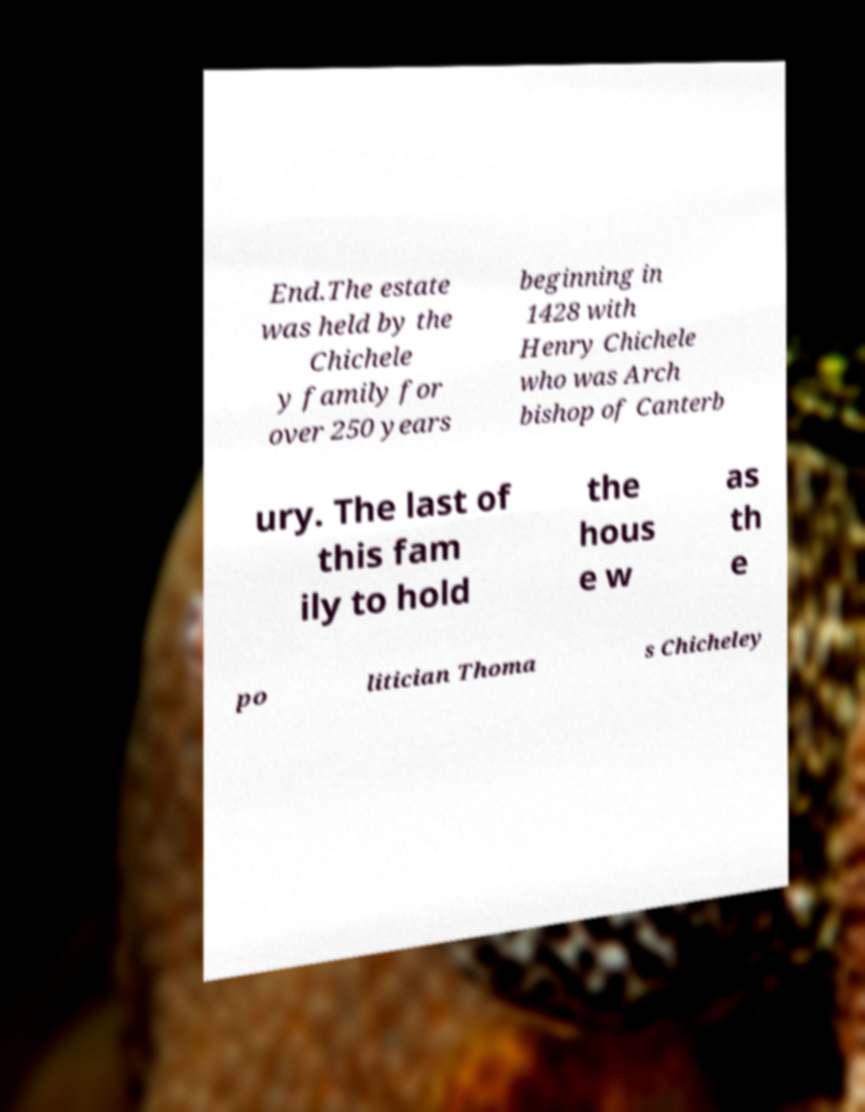Please identify and transcribe the text found in this image. End.The estate was held by the Chichele y family for over 250 years beginning in 1428 with Henry Chichele who was Arch bishop of Canterb ury. The last of this fam ily to hold the hous e w as th e po litician Thoma s Chicheley 